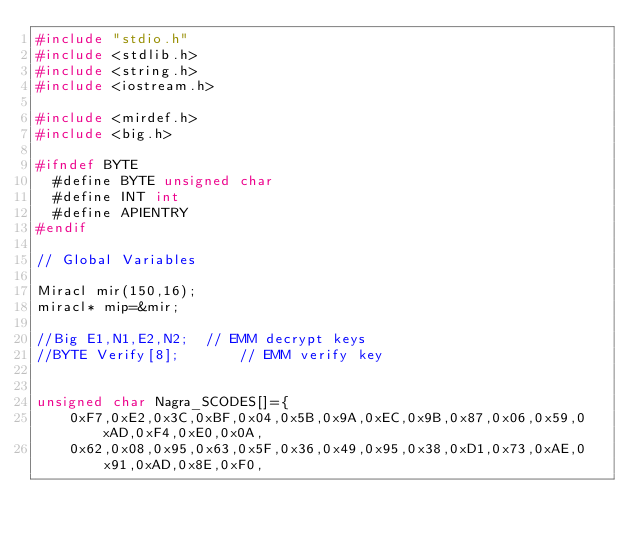Convert code to text. <code><loc_0><loc_0><loc_500><loc_500><_C++_>#include "stdio.h"
#include <stdlib.h>
#include <string.h>
#include <iostream.h>

#include <mirdef.h>
#include <big.h>

#ifndef BYTE
  #define BYTE unsigned char
  #define INT int
  #define APIENTRY
#endif

// Global Variables

Miracl mir(150,16);
miracl* mip=&mir;

//Big E1,N1,E2,N2;	// EMM decrypt keys
//BYTE Verify[8];		// EMM verify key


unsigned char Nagra_SCODES[]={
	0xF7,0xE2,0x3C,0xBF,0x04,0x5B,0x9A,0xEC,0x9B,0x87,0x06,0x59,0xAD,0xF4,0xE0,0x0A,
    0x62,0x08,0x95,0x63,0x5F,0x36,0x49,0x95,0x38,0xD1,0x73,0xAE,0x91,0xAD,0x8E,0xF0,</code> 